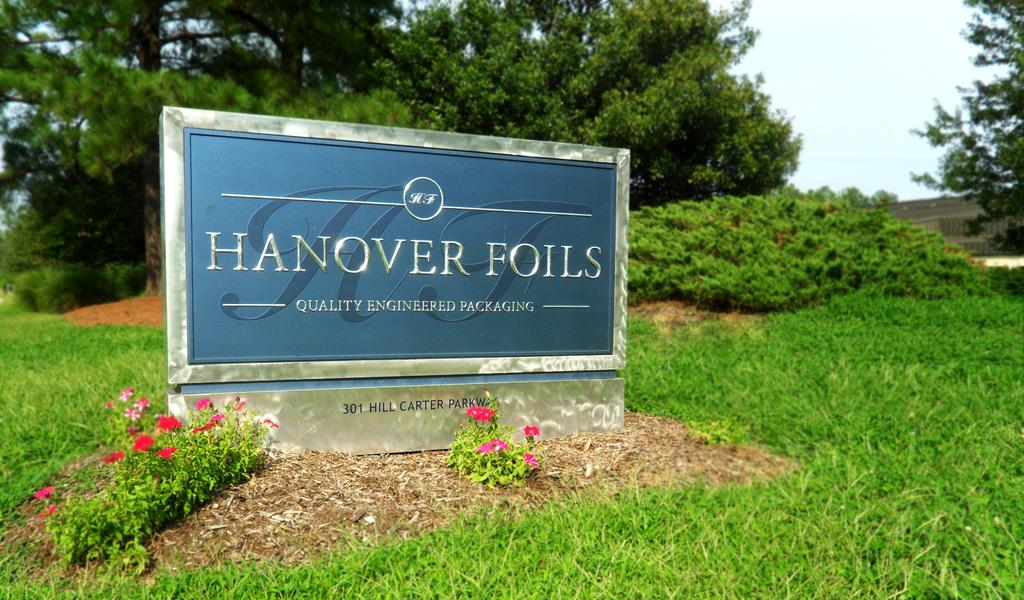What is the main object in the image? There is a name board in the image. What other elements can be seen in the image? There are flowers, grass, trees, and the sky visible in the image. Can you describe the natural environment in the image? The image features grass, trees, and the sky, suggesting a natural setting. How many dimes are scattered on the grass in the image? There are no dimes present in the image; it features a name board, flowers, grass, trees, and the sky. Can you spot a squirrel climbing one of the trees in the image? There is no squirrel visible in the image; it only features a name board, flowers, grass, trees, and the sky. 